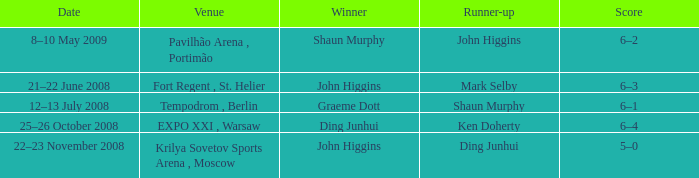When was the match that had Shaun Murphy as runner-up? 12–13 July 2008. 